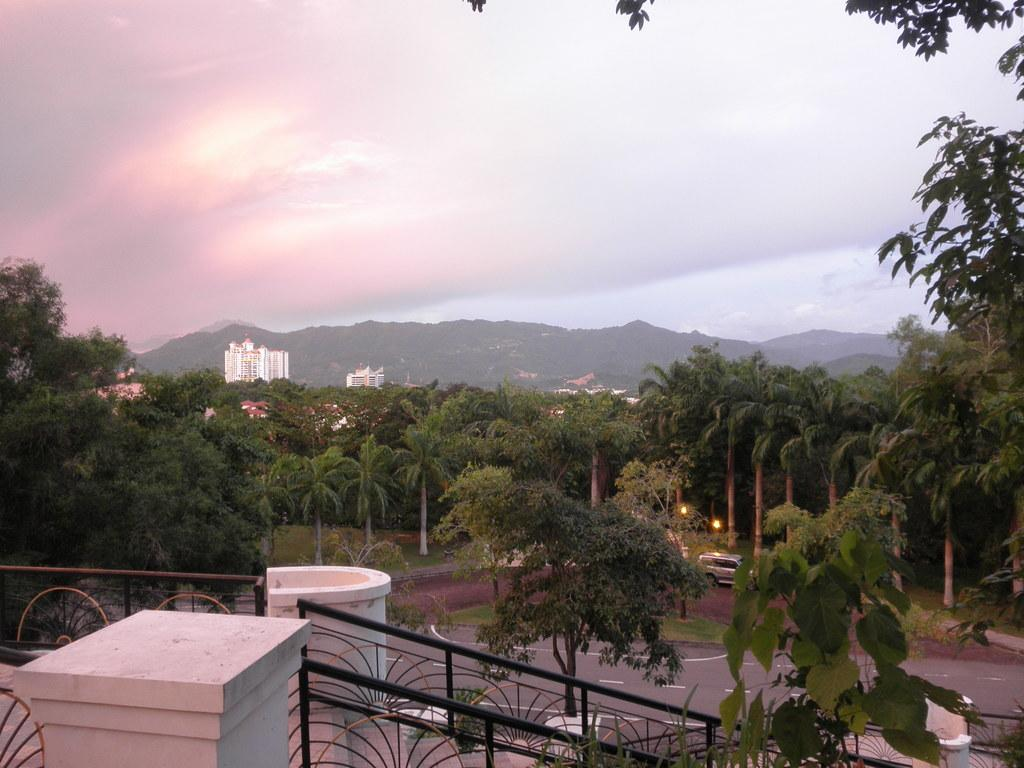What type of natural elements can be seen in the image? There are trees in the image. What type of man-made structures are present in the image? There are buildings in the image. What might be used for safety or support in the image? There is a railing in the image. What mode of transportation can be seen on the road in the image? There is a vehicle on the road in the image. What type of leather is visible on the trees in the image? There is no leather present on the trees in the image; they are natural elements. How many fingers can be seen pointing at the buildings in the image? There are no fingers visible in the image; it only shows trees, buildings, a railing, and a vehicle on the road. 